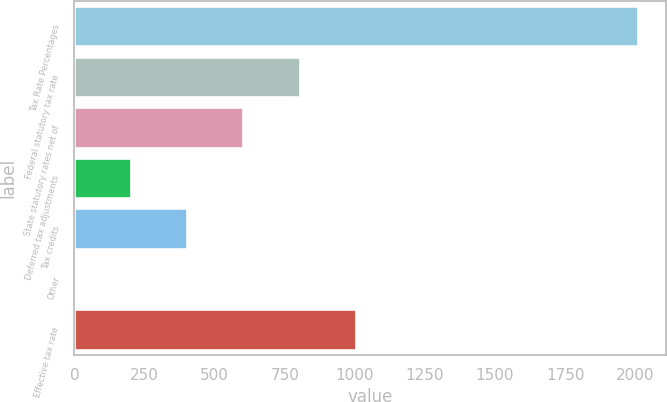Convert chart to OTSL. <chart><loc_0><loc_0><loc_500><loc_500><bar_chart><fcel>Tax Rate Percentages<fcel>Federal statutory tax rate<fcel>State statutory rates net of<fcel>Deferred tax adjustments<fcel>Tax credits<fcel>Other<fcel>Effective tax rate<nl><fcel>2009<fcel>803.66<fcel>602.77<fcel>200.99<fcel>401.88<fcel>0.1<fcel>1004.55<nl></chart> 